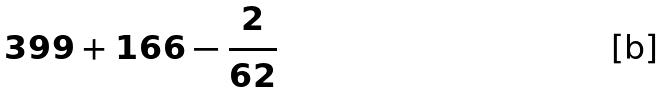<formula> <loc_0><loc_0><loc_500><loc_500>3 9 9 + 1 6 6 - \frac { 2 } { 6 2 }</formula> 